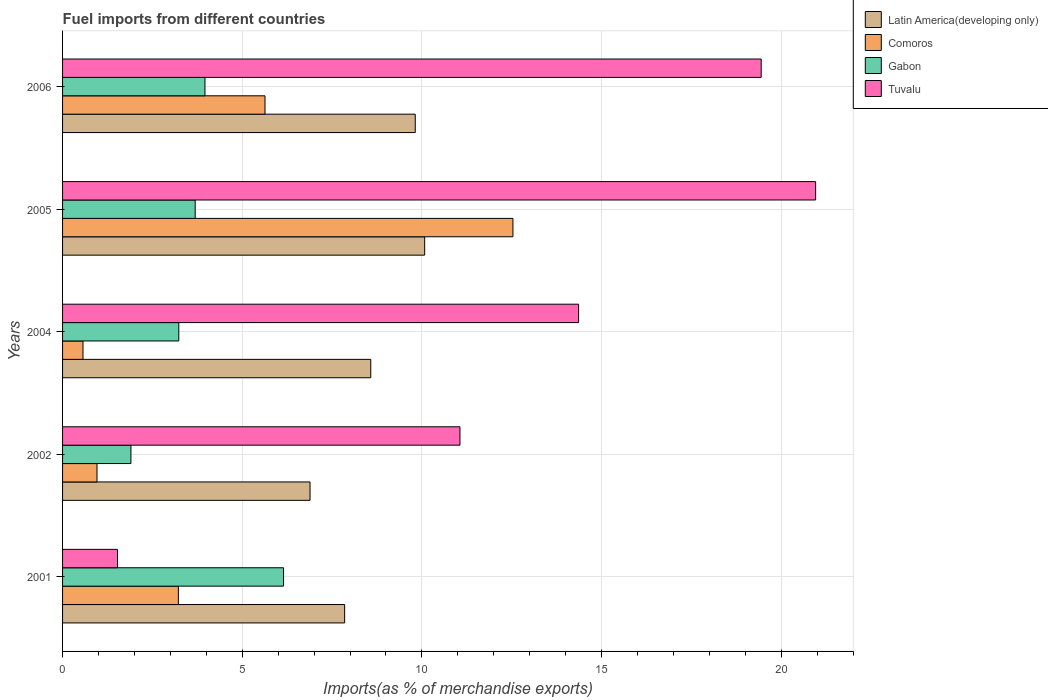How many different coloured bars are there?
Give a very brief answer. 4. How many groups of bars are there?
Your answer should be very brief. 5. Are the number of bars on each tick of the Y-axis equal?
Provide a succinct answer. Yes. In how many cases, is the number of bars for a given year not equal to the number of legend labels?
Give a very brief answer. 0. What is the percentage of imports to different countries in Comoros in 2005?
Your answer should be very brief. 12.53. Across all years, what is the maximum percentage of imports to different countries in Gabon?
Give a very brief answer. 6.15. Across all years, what is the minimum percentage of imports to different countries in Latin America(developing only)?
Give a very brief answer. 6.89. In which year was the percentage of imports to different countries in Gabon maximum?
Your answer should be very brief. 2001. In which year was the percentage of imports to different countries in Latin America(developing only) minimum?
Offer a terse response. 2002. What is the total percentage of imports to different countries in Latin America(developing only) in the graph?
Give a very brief answer. 43.21. What is the difference between the percentage of imports to different countries in Tuvalu in 2001 and that in 2002?
Keep it short and to the point. -9.53. What is the difference between the percentage of imports to different countries in Comoros in 2004 and the percentage of imports to different countries in Tuvalu in 2001?
Your answer should be very brief. -0.96. What is the average percentage of imports to different countries in Tuvalu per year?
Offer a terse response. 13.47. In the year 2002, what is the difference between the percentage of imports to different countries in Comoros and percentage of imports to different countries in Latin America(developing only)?
Make the answer very short. -5.93. In how many years, is the percentage of imports to different countries in Gabon greater than 13 %?
Your answer should be compact. 0. What is the ratio of the percentage of imports to different countries in Tuvalu in 2001 to that in 2006?
Your answer should be compact. 0.08. Is the difference between the percentage of imports to different countries in Comoros in 2001 and 2004 greater than the difference between the percentage of imports to different countries in Latin America(developing only) in 2001 and 2004?
Make the answer very short. Yes. What is the difference between the highest and the second highest percentage of imports to different countries in Gabon?
Give a very brief answer. 2.19. What is the difference between the highest and the lowest percentage of imports to different countries in Latin America(developing only)?
Ensure brevity in your answer.  3.19. Is the sum of the percentage of imports to different countries in Gabon in 2001 and 2004 greater than the maximum percentage of imports to different countries in Comoros across all years?
Your answer should be compact. No. What does the 3rd bar from the top in 2001 represents?
Your answer should be very brief. Comoros. What does the 4th bar from the bottom in 2002 represents?
Your response must be concise. Tuvalu. Is it the case that in every year, the sum of the percentage of imports to different countries in Tuvalu and percentage of imports to different countries in Gabon is greater than the percentage of imports to different countries in Comoros?
Provide a succinct answer. Yes. Are all the bars in the graph horizontal?
Your answer should be very brief. Yes. What is the difference between two consecutive major ticks on the X-axis?
Offer a terse response. 5. Are the values on the major ticks of X-axis written in scientific E-notation?
Give a very brief answer. No. Does the graph contain grids?
Your answer should be very brief. Yes. What is the title of the graph?
Your response must be concise. Fuel imports from different countries. Does "Belarus" appear as one of the legend labels in the graph?
Your response must be concise. No. What is the label or title of the X-axis?
Ensure brevity in your answer.  Imports(as % of merchandise exports). What is the label or title of the Y-axis?
Ensure brevity in your answer.  Years. What is the Imports(as % of merchandise exports) in Latin America(developing only) in 2001?
Provide a short and direct response. 7.85. What is the Imports(as % of merchandise exports) of Comoros in 2001?
Offer a terse response. 3.22. What is the Imports(as % of merchandise exports) of Gabon in 2001?
Offer a terse response. 6.15. What is the Imports(as % of merchandise exports) in Tuvalu in 2001?
Give a very brief answer. 1.53. What is the Imports(as % of merchandise exports) of Latin America(developing only) in 2002?
Your response must be concise. 6.89. What is the Imports(as % of merchandise exports) in Comoros in 2002?
Provide a short and direct response. 0.96. What is the Imports(as % of merchandise exports) in Gabon in 2002?
Provide a succinct answer. 1.9. What is the Imports(as % of merchandise exports) in Tuvalu in 2002?
Give a very brief answer. 11.06. What is the Imports(as % of merchandise exports) of Latin America(developing only) in 2004?
Your answer should be compact. 8.58. What is the Imports(as % of merchandise exports) in Comoros in 2004?
Your response must be concise. 0.57. What is the Imports(as % of merchandise exports) of Gabon in 2004?
Offer a terse response. 3.23. What is the Imports(as % of merchandise exports) of Tuvalu in 2004?
Provide a succinct answer. 14.36. What is the Imports(as % of merchandise exports) in Latin America(developing only) in 2005?
Your answer should be compact. 10.08. What is the Imports(as % of merchandise exports) in Comoros in 2005?
Your response must be concise. 12.53. What is the Imports(as % of merchandise exports) of Gabon in 2005?
Offer a terse response. 3.69. What is the Imports(as % of merchandise exports) of Tuvalu in 2005?
Provide a succinct answer. 20.96. What is the Imports(as % of merchandise exports) of Latin America(developing only) in 2006?
Offer a very short reply. 9.82. What is the Imports(as % of merchandise exports) in Comoros in 2006?
Keep it short and to the point. 5.63. What is the Imports(as % of merchandise exports) of Gabon in 2006?
Keep it short and to the point. 3.96. What is the Imports(as % of merchandise exports) of Tuvalu in 2006?
Offer a terse response. 19.44. Across all years, what is the maximum Imports(as % of merchandise exports) of Latin America(developing only)?
Your answer should be compact. 10.08. Across all years, what is the maximum Imports(as % of merchandise exports) of Comoros?
Offer a very short reply. 12.53. Across all years, what is the maximum Imports(as % of merchandise exports) in Gabon?
Your response must be concise. 6.15. Across all years, what is the maximum Imports(as % of merchandise exports) in Tuvalu?
Provide a short and direct response. 20.96. Across all years, what is the minimum Imports(as % of merchandise exports) in Latin America(developing only)?
Make the answer very short. 6.89. Across all years, what is the minimum Imports(as % of merchandise exports) in Comoros?
Your response must be concise. 0.57. Across all years, what is the minimum Imports(as % of merchandise exports) in Gabon?
Ensure brevity in your answer.  1.9. Across all years, what is the minimum Imports(as % of merchandise exports) of Tuvalu?
Provide a succinct answer. 1.53. What is the total Imports(as % of merchandise exports) in Latin America(developing only) in the graph?
Provide a short and direct response. 43.21. What is the total Imports(as % of merchandise exports) in Comoros in the graph?
Provide a succinct answer. 22.92. What is the total Imports(as % of merchandise exports) of Gabon in the graph?
Give a very brief answer. 18.94. What is the total Imports(as % of merchandise exports) in Tuvalu in the graph?
Your answer should be compact. 67.36. What is the difference between the Imports(as % of merchandise exports) in Latin America(developing only) in 2001 and that in 2002?
Your response must be concise. 0.96. What is the difference between the Imports(as % of merchandise exports) in Comoros in 2001 and that in 2002?
Provide a short and direct response. 2.26. What is the difference between the Imports(as % of merchandise exports) of Gabon in 2001 and that in 2002?
Make the answer very short. 4.25. What is the difference between the Imports(as % of merchandise exports) of Tuvalu in 2001 and that in 2002?
Your response must be concise. -9.53. What is the difference between the Imports(as % of merchandise exports) of Latin America(developing only) in 2001 and that in 2004?
Your response must be concise. -0.73. What is the difference between the Imports(as % of merchandise exports) of Comoros in 2001 and that in 2004?
Provide a short and direct response. 2.65. What is the difference between the Imports(as % of merchandise exports) in Gabon in 2001 and that in 2004?
Your response must be concise. 2.92. What is the difference between the Imports(as % of merchandise exports) of Tuvalu in 2001 and that in 2004?
Keep it short and to the point. -12.83. What is the difference between the Imports(as % of merchandise exports) in Latin America(developing only) in 2001 and that in 2005?
Make the answer very short. -2.23. What is the difference between the Imports(as % of merchandise exports) of Comoros in 2001 and that in 2005?
Provide a succinct answer. -9.31. What is the difference between the Imports(as % of merchandise exports) of Gabon in 2001 and that in 2005?
Provide a succinct answer. 2.46. What is the difference between the Imports(as % of merchandise exports) of Tuvalu in 2001 and that in 2005?
Ensure brevity in your answer.  -19.43. What is the difference between the Imports(as % of merchandise exports) in Latin America(developing only) in 2001 and that in 2006?
Your response must be concise. -1.97. What is the difference between the Imports(as % of merchandise exports) in Comoros in 2001 and that in 2006?
Your response must be concise. -2.41. What is the difference between the Imports(as % of merchandise exports) of Gabon in 2001 and that in 2006?
Offer a terse response. 2.19. What is the difference between the Imports(as % of merchandise exports) of Tuvalu in 2001 and that in 2006?
Your answer should be very brief. -17.91. What is the difference between the Imports(as % of merchandise exports) in Latin America(developing only) in 2002 and that in 2004?
Ensure brevity in your answer.  -1.69. What is the difference between the Imports(as % of merchandise exports) of Comoros in 2002 and that in 2004?
Your answer should be very brief. 0.39. What is the difference between the Imports(as % of merchandise exports) of Gabon in 2002 and that in 2004?
Provide a short and direct response. -1.33. What is the difference between the Imports(as % of merchandise exports) in Tuvalu in 2002 and that in 2004?
Offer a terse response. -3.3. What is the difference between the Imports(as % of merchandise exports) in Latin America(developing only) in 2002 and that in 2005?
Your answer should be compact. -3.19. What is the difference between the Imports(as % of merchandise exports) of Comoros in 2002 and that in 2005?
Your answer should be compact. -11.58. What is the difference between the Imports(as % of merchandise exports) of Gabon in 2002 and that in 2005?
Keep it short and to the point. -1.79. What is the difference between the Imports(as % of merchandise exports) of Tuvalu in 2002 and that in 2005?
Provide a short and direct response. -9.9. What is the difference between the Imports(as % of merchandise exports) of Latin America(developing only) in 2002 and that in 2006?
Make the answer very short. -2.93. What is the difference between the Imports(as % of merchandise exports) of Comoros in 2002 and that in 2006?
Your response must be concise. -4.68. What is the difference between the Imports(as % of merchandise exports) in Gabon in 2002 and that in 2006?
Give a very brief answer. -2.06. What is the difference between the Imports(as % of merchandise exports) in Tuvalu in 2002 and that in 2006?
Keep it short and to the point. -8.38. What is the difference between the Imports(as % of merchandise exports) in Latin America(developing only) in 2004 and that in 2005?
Your response must be concise. -1.5. What is the difference between the Imports(as % of merchandise exports) of Comoros in 2004 and that in 2005?
Give a very brief answer. -11.97. What is the difference between the Imports(as % of merchandise exports) in Gabon in 2004 and that in 2005?
Your answer should be very brief. -0.46. What is the difference between the Imports(as % of merchandise exports) of Tuvalu in 2004 and that in 2005?
Ensure brevity in your answer.  -6.6. What is the difference between the Imports(as % of merchandise exports) of Latin America(developing only) in 2004 and that in 2006?
Provide a short and direct response. -1.24. What is the difference between the Imports(as % of merchandise exports) of Comoros in 2004 and that in 2006?
Ensure brevity in your answer.  -5.07. What is the difference between the Imports(as % of merchandise exports) of Gabon in 2004 and that in 2006?
Give a very brief answer. -0.73. What is the difference between the Imports(as % of merchandise exports) of Tuvalu in 2004 and that in 2006?
Your answer should be compact. -5.08. What is the difference between the Imports(as % of merchandise exports) in Latin America(developing only) in 2005 and that in 2006?
Make the answer very short. 0.26. What is the difference between the Imports(as % of merchandise exports) in Comoros in 2005 and that in 2006?
Provide a short and direct response. 6.9. What is the difference between the Imports(as % of merchandise exports) in Gabon in 2005 and that in 2006?
Offer a terse response. -0.27. What is the difference between the Imports(as % of merchandise exports) of Tuvalu in 2005 and that in 2006?
Offer a very short reply. 1.52. What is the difference between the Imports(as % of merchandise exports) in Latin America(developing only) in 2001 and the Imports(as % of merchandise exports) in Comoros in 2002?
Offer a very short reply. 6.89. What is the difference between the Imports(as % of merchandise exports) in Latin America(developing only) in 2001 and the Imports(as % of merchandise exports) in Gabon in 2002?
Ensure brevity in your answer.  5.95. What is the difference between the Imports(as % of merchandise exports) of Latin America(developing only) in 2001 and the Imports(as % of merchandise exports) of Tuvalu in 2002?
Ensure brevity in your answer.  -3.21. What is the difference between the Imports(as % of merchandise exports) of Comoros in 2001 and the Imports(as % of merchandise exports) of Gabon in 2002?
Offer a very short reply. 1.32. What is the difference between the Imports(as % of merchandise exports) in Comoros in 2001 and the Imports(as % of merchandise exports) in Tuvalu in 2002?
Give a very brief answer. -7.84. What is the difference between the Imports(as % of merchandise exports) in Gabon in 2001 and the Imports(as % of merchandise exports) in Tuvalu in 2002?
Offer a terse response. -4.91. What is the difference between the Imports(as % of merchandise exports) of Latin America(developing only) in 2001 and the Imports(as % of merchandise exports) of Comoros in 2004?
Keep it short and to the point. 7.28. What is the difference between the Imports(as % of merchandise exports) of Latin America(developing only) in 2001 and the Imports(as % of merchandise exports) of Gabon in 2004?
Make the answer very short. 4.62. What is the difference between the Imports(as % of merchandise exports) in Latin America(developing only) in 2001 and the Imports(as % of merchandise exports) in Tuvalu in 2004?
Ensure brevity in your answer.  -6.51. What is the difference between the Imports(as % of merchandise exports) in Comoros in 2001 and the Imports(as % of merchandise exports) in Gabon in 2004?
Ensure brevity in your answer.  -0.01. What is the difference between the Imports(as % of merchandise exports) of Comoros in 2001 and the Imports(as % of merchandise exports) of Tuvalu in 2004?
Your response must be concise. -11.14. What is the difference between the Imports(as % of merchandise exports) in Gabon in 2001 and the Imports(as % of merchandise exports) in Tuvalu in 2004?
Offer a very short reply. -8.21. What is the difference between the Imports(as % of merchandise exports) in Latin America(developing only) in 2001 and the Imports(as % of merchandise exports) in Comoros in 2005?
Keep it short and to the point. -4.68. What is the difference between the Imports(as % of merchandise exports) in Latin America(developing only) in 2001 and the Imports(as % of merchandise exports) in Gabon in 2005?
Ensure brevity in your answer.  4.16. What is the difference between the Imports(as % of merchandise exports) of Latin America(developing only) in 2001 and the Imports(as % of merchandise exports) of Tuvalu in 2005?
Your response must be concise. -13.11. What is the difference between the Imports(as % of merchandise exports) of Comoros in 2001 and the Imports(as % of merchandise exports) of Gabon in 2005?
Provide a succinct answer. -0.47. What is the difference between the Imports(as % of merchandise exports) of Comoros in 2001 and the Imports(as % of merchandise exports) of Tuvalu in 2005?
Provide a short and direct response. -17.74. What is the difference between the Imports(as % of merchandise exports) in Gabon in 2001 and the Imports(as % of merchandise exports) in Tuvalu in 2005?
Your answer should be compact. -14.81. What is the difference between the Imports(as % of merchandise exports) of Latin America(developing only) in 2001 and the Imports(as % of merchandise exports) of Comoros in 2006?
Provide a succinct answer. 2.22. What is the difference between the Imports(as % of merchandise exports) of Latin America(developing only) in 2001 and the Imports(as % of merchandise exports) of Gabon in 2006?
Give a very brief answer. 3.89. What is the difference between the Imports(as % of merchandise exports) of Latin America(developing only) in 2001 and the Imports(as % of merchandise exports) of Tuvalu in 2006?
Ensure brevity in your answer.  -11.59. What is the difference between the Imports(as % of merchandise exports) of Comoros in 2001 and the Imports(as % of merchandise exports) of Gabon in 2006?
Offer a very short reply. -0.74. What is the difference between the Imports(as % of merchandise exports) of Comoros in 2001 and the Imports(as % of merchandise exports) of Tuvalu in 2006?
Ensure brevity in your answer.  -16.22. What is the difference between the Imports(as % of merchandise exports) in Gabon in 2001 and the Imports(as % of merchandise exports) in Tuvalu in 2006?
Provide a succinct answer. -13.29. What is the difference between the Imports(as % of merchandise exports) of Latin America(developing only) in 2002 and the Imports(as % of merchandise exports) of Comoros in 2004?
Your answer should be compact. 6.32. What is the difference between the Imports(as % of merchandise exports) in Latin America(developing only) in 2002 and the Imports(as % of merchandise exports) in Gabon in 2004?
Provide a succinct answer. 3.65. What is the difference between the Imports(as % of merchandise exports) in Latin America(developing only) in 2002 and the Imports(as % of merchandise exports) in Tuvalu in 2004?
Offer a very short reply. -7.47. What is the difference between the Imports(as % of merchandise exports) in Comoros in 2002 and the Imports(as % of merchandise exports) in Gabon in 2004?
Provide a succinct answer. -2.28. What is the difference between the Imports(as % of merchandise exports) in Comoros in 2002 and the Imports(as % of merchandise exports) in Tuvalu in 2004?
Offer a terse response. -13.4. What is the difference between the Imports(as % of merchandise exports) of Gabon in 2002 and the Imports(as % of merchandise exports) of Tuvalu in 2004?
Your answer should be very brief. -12.46. What is the difference between the Imports(as % of merchandise exports) of Latin America(developing only) in 2002 and the Imports(as % of merchandise exports) of Comoros in 2005?
Provide a short and direct response. -5.65. What is the difference between the Imports(as % of merchandise exports) of Latin America(developing only) in 2002 and the Imports(as % of merchandise exports) of Gabon in 2005?
Offer a very short reply. 3.2. What is the difference between the Imports(as % of merchandise exports) in Latin America(developing only) in 2002 and the Imports(as % of merchandise exports) in Tuvalu in 2005?
Give a very brief answer. -14.07. What is the difference between the Imports(as % of merchandise exports) of Comoros in 2002 and the Imports(as % of merchandise exports) of Gabon in 2005?
Offer a terse response. -2.73. What is the difference between the Imports(as % of merchandise exports) in Comoros in 2002 and the Imports(as % of merchandise exports) in Tuvalu in 2005?
Provide a short and direct response. -20. What is the difference between the Imports(as % of merchandise exports) in Gabon in 2002 and the Imports(as % of merchandise exports) in Tuvalu in 2005?
Your answer should be compact. -19.06. What is the difference between the Imports(as % of merchandise exports) in Latin America(developing only) in 2002 and the Imports(as % of merchandise exports) in Comoros in 2006?
Offer a very short reply. 1.25. What is the difference between the Imports(as % of merchandise exports) of Latin America(developing only) in 2002 and the Imports(as % of merchandise exports) of Gabon in 2006?
Provide a succinct answer. 2.92. What is the difference between the Imports(as % of merchandise exports) in Latin America(developing only) in 2002 and the Imports(as % of merchandise exports) in Tuvalu in 2006?
Keep it short and to the point. -12.56. What is the difference between the Imports(as % of merchandise exports) of Comoros in 2002 and the Imports(as % of merchandise exports) of Gabon in 2006?
Your answer should be compact. -3. What is the difference between the Imports(as % of merchandise exports) in Comoros in 2002 and the Imports(as % of merchandise exports) in Tuvalu in 2006?
Make the answer very short. -18.49. What is the difference between the Imports(as % of merchandise exports) in Gabon in 2002 and the Imports(as % of merchandise exports) in Tuvalu in 2006?
Provide a short and direct response. -17.54. What is the difference between the Imports(as % of merchandise exports) of Latin America(developing only) in 2004 and the Imports(as % of merchandise exports) of Comoros in 2005?
Your answer should be compact. -3.96. What is the difference between the Imports(as % of merchandise exports) of Latin America(developing only) in 2004 and the Imports(as % of merchandise exports) of Gabon in 2005?
Your answer should be compact. 4.89. What is the difference between the Imports(as % of merchandise exports) of Latin America(developing only) in 2004 and the Imports(as % of merchandise exports) of Tuvalu in 2005?
Provide a short and direct response. -12.38. What is the difference between the Imports(as % of merchandise exports) in Comoros in 2004 and the Imports(as % of merchandise exports) in Gabon in 2005?
Offer a very short reply. -3.12. What is the difference between the Imports(as % of merchandise exports) in Comoros in 2004 and the Imports(as % of merchandise exports) in Tuvalu in 2005?
Provide a succinct answer. -20.39. What is the difference between the Imports(as % of merchandise exports) in Gabon in 2004 and the Imports(as % of merchandise exports) in Tuvalu in 2005?
Keep it short and to the point. -17.73. What is the difference between the Imports(as % of merchandise exports) of Latin America(developing only) in 2004 and the Imports(as % of merchandise exports) of Comoros in 2006?
Keep it short and to the point. 2.94. What is the difference between the Imports(as % of merchandise exports) of Latin America(developing only) in 2004 and the Imports(as % of merchandise exports) of Gabon in 2006?
Keep it short and to the point. 4.62. What is the difference between the Imports(as % of merchandise exports) of Latin America(developing only) in 2004 and the Imports(as % of merchandise exports) of Tuvalu in 2006?
Make the answer very short. -10.87. What is the difference between the Imports(as % of merchandise exports) of Comoros in 2004 and the Imports(as % of merchandise exports) of Gabon in 2006?
Your answer should be very brief. -3.39. What is the difference between the Imports(as % of merchandise exports) in Comoros in 2004 and the Imports(as % of merchandise exports) in Tuvalu in 2006?
Keep it short and to the point. -18.88. What is the difference between the Imports(as % of merchandise exports) in Gabon in 2004 and the Imports(as % of merchandise exports) in Tuvalu in 2006?
Provide a short and direct response. -16.21. What is the difference between the Imports(as % of merchandise exports) in Latin America(developing only) in 2005 and the Imports(as % of merchandise exports) in Comoros in 2006?
Your answer should be compact. 4.44. What is the difference between the Imports(as % of merchandise exports) in Latin America(developing only) in 2005 and the Imports(as % of merchandise exports) in Gabon in 2006?
Offer a very short reply. 6.12. What is the difference between the Imports(as % of merchandise exports) in Latin America(developing only) in 2005 and the Imports(as % of merchandise exports) in Tuvalu in 2006?
Your answer should be compact. -9.37. What is the difference between the Imports(as % of merchandise exports) of Comoros in 2005 and the Imports(as % of merchandise exports) of Gabon in 2006?
Your response must be concise. 8.57. What is the difference between the Imports(as % of merchandise exports) of Comoros in 2005 and the Imports(as % of merchandise exports) of Tuvalu in 2006?
Offer a very short reply. -6.91. What is the difference between the Imports(as % of merchandise exports) of Gabon in 2005 and the Imports(as % of merchandise exports) of Tuvalu in 2006?
Provide a succinct answer. -15.75. What is the average Imports(as % of merchandise exports) of Latin America(developing only) per year?
Your response must be concise. 8.64. What is the average Imports(as % of merchandise exports) in Comoros per year?
Your response must be concise. 4.58. What is the average Imports(as % of merchandise exports) in Gabon per year?
Provide a succinct answer. 3.79. What is the average Imports(as % of merchandise exports) in Tuvalu per year?
Your answer should be very brief. 13.47. In the year 2001, what is the difference between the Imports(as % of merchandise exports) in Latin America(developing only) and Imports(as % of merchandise exports) in Comoros?
Your answer should be compact. 4.63. In the year 2001, what is the difference between the Imports(as % of merchandise exports) in Latin America(developing only) and Imports(as % of merchandise exports) in Gabon?
Offer a very short reply. 1.7. In the year 2001, what is the difference between the Imports(as % of merchandise exports) of Latin America(developing only) and Imports(as % of merchandise exports) of Tuvalu?
Your response must be concise. 6.32. In the year 2001, what is the difference between the Imports(as % of merchandise exports) in Comoros and Imports(as % of merchandise exports) in Gabon?
Make the answer very short. -2.93. In the year 2001, what is the difference between the Imports(as % of merchandise exports) in Comoros and Imports(as % of merchandise exports) in Tuvalu?
Give a very brief answer. 1.69. In the year 2001, what is the difference between the Imports(as % of merchandise exports) of Gabon and Imports(as % of merchandise exports) of Tuvalu?
Give a very brief answer. 4.62. In the year 2002, what is the difference between the Imports(as % of merchandise exports) of Latin America(developing only) and Imports(as % of merchandise exports) of Comoros?
Your answer should be compact. 5.93. In the year 2002, what is the difference between the Imports(as % of merchandise exports) of Latin America(developing only) and Imports(as % of merchandise exports) of Gabon?
Offer a very short reply. 4.99. In the year 2002, what is the difference between the Imports(as % of merchandise exports) of Latin America(developing only) and Imports(as % of merchandise exports) of Tuvalu?
Keep it short and to the point. -4.17. In the year 2002, what is the difference between the Imports(as % of merchandise exports) of Comoros and Imports(as % of merchandise exports) of Gabon?
Offer a terse response. -0.94. In the year 2002, what is the difference between the Imports(as % of merchandise exports) in Comoros and Imports(as % of merchandise exports) in Tuvalu?
Your answer should be compact. -10.1. In the year 2002, what is the difference between the Imports(as % of merchandise exports) in Gabon and Imports(as % of merchandise exports) in Tuvalu?
Keep it short and to the point. -9.16. In the year 2004, what is the difference between the Imports(as % of merchandise exports) of Latin America(developing only) and Imports(as % of merchandise exports) of Comoros?
Offer a terse response. 8.01. In the year 2004, what is the difference between the Imports(as % of merchandise exports) of Latin America(developing only) and Imports(as % of merchandise exports) of Gabon?
Offer a very short reply. 5.34. In the year 2004, what is the difference between the Imports(as % of merchandise exports) of Latin America(developing only) and Imports(as % of merchandise exports) of Tuvalu?
Ensure brevity in your answer.  -5.78. In the year 2004, what is the difference between the Imports(as % of merchandise exports) of Comoros and Imports(as % of merchandise exports) of Gabon?
Your answer should be compact. -2.67. In the year 2004, what is the difference between the Imports(as % of merchandise exports) in Comoros and Imports(as % of merchandise exports) in Tuvalu?
Keep it short and to the point. -13.79. In the year 2004, what is the difference between the Imports(as % of merchandise exports) of Gabon and Imports(as % of merchandise exports) of Tuvalu?
Give a very brief answer. -11.13. In the year 2005, what is the difference between the Imports(as % of merchandise exports) of Latin America(developing only) and Imports(as % of merchandise exports) of Comoros?
Provide a succinct answer. -2.46. In the year 2005, what is the difference between the Imports(as % of merchandise exports) of Latin America(developing only) and Imports(as % of merchandise exports) of Gabon?
Your response must be concise. 6.39. In the year 2005, what is the difference between the Imports(as % of merchandise exports) in Latin America(developing only) and Imports(as % of merchandise exports) in Tuvalu?
Offer a very short reply. -10.88. In the year 2005, what is the difference between the Imports(as % of merchandise exports) in Comoros and Imports(as % of merchandise exports) in Gabon?
Your answer should be compact. 8.84. In the year 2005, what is the difference between the Imports(as % of merchandise exports) in Comoros and Imports(as % of merchandise exports) in Tuvalu?
Give a very brief answer. -8.43. In the year 2005, what is the difference between the Imports(as % of merchandise exports) of Gabon and Imports(as % of merchandise exports) of Tuvalu?
Your response must be concise. -17.27. In the year 2006, what is the difference between the Imports(as % of merchandise exports) of Latin America(developing only) and Imports(as % of merchandise exports) of Comoros?
Make the answer very short. 4.18. In the year 2006, what is the difference between the Imports(as % of merchandise exports) in Latin America(developing only) and Imports(as % of merchandise exports) in Gabon?
Make the answer very short. 5.85. In the year 2006, what is the difference between the Imports(as % of merchandise exports) of Latin America(developing only) and Imports(as % of merchandise exports) of Tuvalu?
Your answer should be very brief. -9.63. In the year 2006, what is the difference between the Imports(as % of merchandise exports) of Comoros and Imports(as % of merchandise exports) of Gabon?
Ensure brevity in your answer.  1.67. In the year 2006, what is the difference between the Imports(as % of merchandise exports) in Comoros and Imports(as % of merchandise exports) in Tuvalu?
Your response must be concise. -13.81. In the year 2006, what is the difference between the Imports(as % of merchandise exports) of Gabon and Imports(as % of merchandise exports) of Tuvalu?
Keep it short and to the point. -15.48. What is the ratio of the Imports(as % of merchandise exports) in Latin America(developing only) in 2001 to that in 2002?
Provide a succinct answer. 1.14. What is the ratio of the Imports(as % of merchandise exports) in Comoros in 2001 to that in 2002?
Keep it short and to the point. 3.36. What is the ratio of the Imports(as % of merchandise exports) of Gabon in 2001 to that in 2002?
Give a very brief answer. 3.23. What is the ratio of the Imports(as % of merchandise exports) of Tuvalu in 2001 to that in 2002?
Provide a short and direct response. 0.14. What is the ratio of the Imports(as % of merchandise exports) of Latin America(developing only) in 2001 to that in 2004?
Provide a short and direct response. 0.92. What is the ratio of the Imports(as % of merchandise exports) of Comoros in 2001 to that in 2004?
Provide a succinct answer. 5.67. What is the ratio of the Imports(as % of merchandise exports) in Gabon in 2001 to that in 2004?
Offer a terse response. 1.9. What is the ratio of the Imports(as % of merchandise exports) in Tuvalu in 2001 to that in 2004?
Your answer should be very brief. 0.11. What is the ratio of the Imports(as % of merchandise exports) of Latin America(developing only) in 2001 to that in 2005?
Give a very brief answer. 0.78. What is the ratio of the Imports(as % of merchandise exports) in Comoros in 2001 to that in 2005?
Offer a terse response. 0.26. What is the ratio of the Imports(as % of merchandise exports) of Gabon in 2001 to that in 2005?
Give a very brief answer. 1.67. What is the ratio of the Imports(as % of merchandise exports) in Tuvalu in 2001 to that in 2005?
Offer a terse response. 0.07. What is the ratio of the Imports(as % of merchandise exports) in Latin America(developing only) in 2001 to that in 2006?
Provide a short and direct response. 0.8. What is the ratio of the Imports(as % of merchandise exports) in Comoros in 2001 to that in 2006?
Provide a succinct answer. 0.57. What is the ratio of the Imports(as % of merchandise exports) in Gabon in 2001 to that in 2006?
Offer a terse response. 1.55. What is the ratio of the Imports(as % of merchandise exports) of Tuvalu in 2001 to that in 2006?
Provide a succinct answer. 0.08. What is the ratio of the Imports(as % of merchandise exports) in Latin America(developing only) in 2002 to that in 2004?
Make the answer very short. 0.8. What is the ratio of the Imports(as % of merchandise exports) in Comoros in 2002 to that in 2004?
Your answer should be very brief. 1.69. What is the ratio of the Imports(as % of merchandise exports) of Gabon in 2002 to that in 2004?
Keep it short and to the point. 0.59. What is the ratio of the Imports(as % of merchandise exports) of Tuvalu in 2002 to that in 2004?
Offer a terse response. 0.77. What is the ratio of the Imports(as % of merchandise exports) of Latin America(developing only) in 2002 to that in 2005?
Offer a terse response. 0.68. What is the ratio of the Imports(as % of merchandise exports) of Comoros in 2002 to that in 2005?
Keep it short and to the point. 0.08. What is the ratio of the Imports(as % of merchandise exports) in Gabon in 2002 to that in 2005?
Offer a terse response. 0.52. What is the ratio of the Imports(as % of merchandise exports) in Tuvalu in 2002 to that in 2005?
Give a very brief answer. 0.53. What is the ratio of the Imports(as % of merchandise exports) of Latin America(developing only) in 2002 to that in 2006?
Provide a short and direct response. 0.7. What is the ratio of the Imports(as % of merchandise exports) in Comoros in 2002 to that in 2006?
Your response must be concise. 0.17. What is the ratio of the Imports(as % of merchandise exports) of Gabon in 2002 to that in 2006?
Ensure brevity in your answer.  0.48. What is the ratio of the Imports(as % of merchandise exports) of Tuvalu in 2002 to that in 2006?
Your answer should be compact. 0.57. What is the ratio of the Imports(as % of merchandise exports) of Latin America(developing only) in 2004 to that in 2005?
Your answer should be compact. 0.85. What is the ratio of the Imports(as % of merchandise exports) of Comoros in 2004 to that in 2005?
Offer a terse response. 0.05. What is the ratio of the Imports(as % of merchandise exports) of Gabon in 2004 to that in 2005?
Your answer should be compact. 0.88. What is the ratio of the Imports(as % of merchandise exports) in Tuvalu in 2004 to that in 2005?
Provide a succinct answer. 0.69. What is the ratio of the Imports(as % of merchandise exports) of Latin America(developing only) in 2004 to that in 2006?
Provide a succinct answer. 0.87. What is the ratio of the Imports(as % of merchandise exports) of Comoros in 2004 to that in 2006?
Your answer should be very brief. 0.1. What is the ratio of the Imports(as % of merchandise exports) in Gabon in 2004 to that in 2006?
Your response must be concise. 0.82. What is the ratio of the Imports(as % of merchandise exports) in Tuvalu in 2004 to that in 2006?
Offer a terse response. 0.74. What is the ratio of the Imports(as % of merchandise exports) of Latin America(developing only) in 2005 to that in 2006?
Ensure brevity in your answer.  1.03. What is the ratio of the Imports(as % of merchandise exports) of Comoros in 2005 to that in 2006?
Offer a terse response. 2.22. What is the ratio of the Imports(as % of merchandise exports) in Gabon in 2005 to that in 2006?
Provide a short and direct response. 0.93. What is the ratio of the Imports(as % of merchandise exports) in Tuvalu in 2005 to that in 2006?
Make the answer very short. 1.08. What is the difference between the highest and the second highest Imports(as % of merchandise exports) in Latin America(developing only)?
Offer a terse response. 0.26. What is the difference between the highest and the second highest Imports(as % of merchandise exports) of Comoros?
Your answer should be very brief. 6.9. What is the difference between the highest and the second highest Imports(as % of merchandise exports) in Gabon?
Your answer should be compact. 2.19. What is the difference between the highest and the second highest Imports(as % of merchandise exports) in Tuvalu?
Give a very brief answer. 1.52. What is the difference between the highest and the lowest Imports(as % of merchandise exports) of Latin America(developing only)?
Offer a very short reply. 3.19. What is the difference between the highest and the lowest Imports(as % of merchandise exports) of Comoros?
Keep it short and to the point. 11.97. What is the difference between the highest and the lowest Imports(as % of merchandise exports) in Gabon?
Offer a very short reply. 4.25. What is the difference between the highest and the lowest Imports(as % of merchandise exports) in Tuvalu?
Provide a short and direct response. 19.43. 